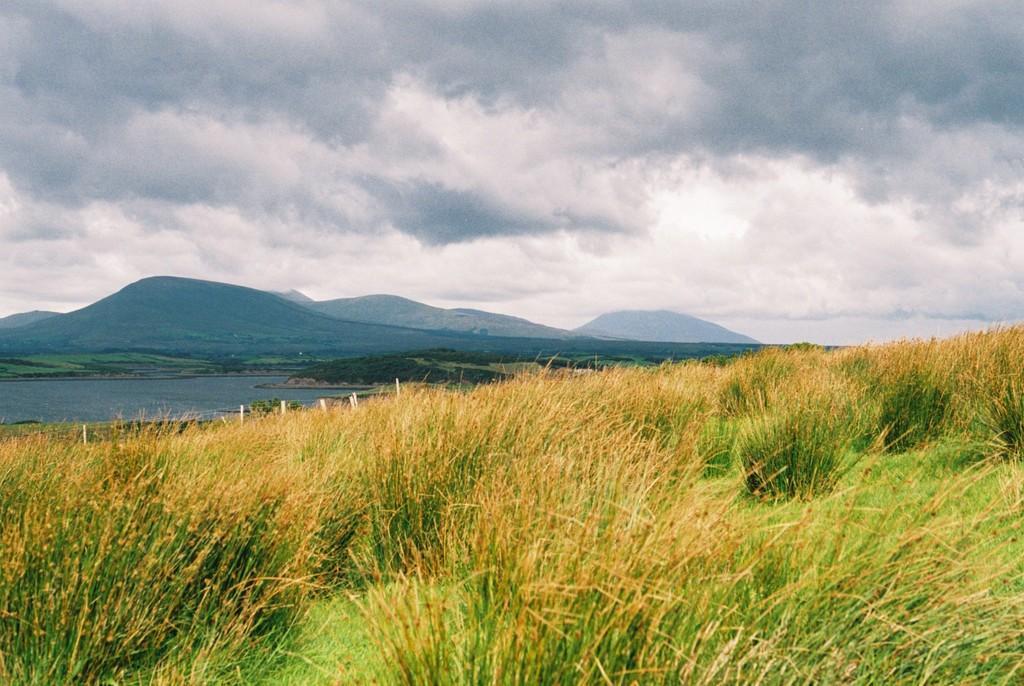Describe this image in one or two sentences. In this image there is grassland. Left side there is water. Beside there is land having few trees. Behind there are hills. Top of image there is sky with some clouds. 